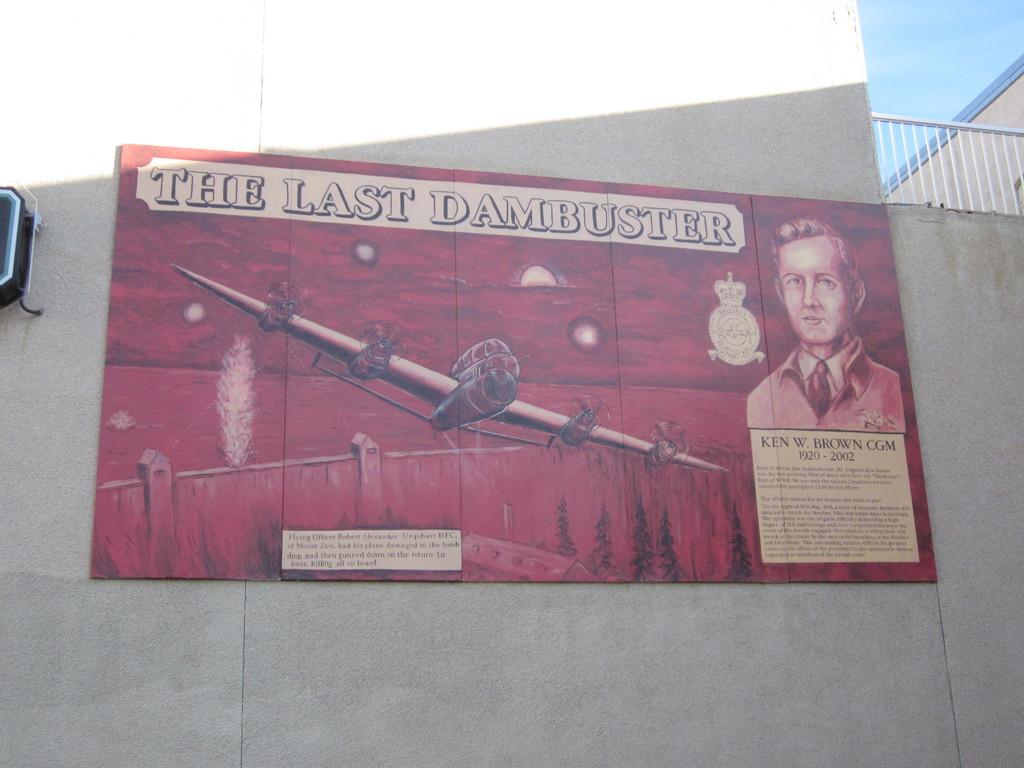When did ken w. brown die according to the poster?
Your answer should be compact. 2002. 